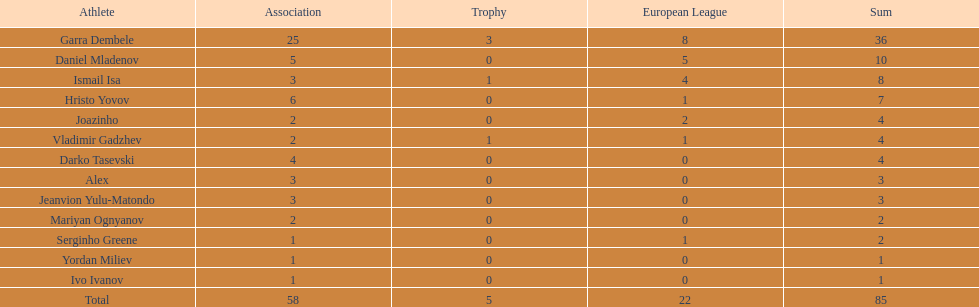Which total is higher, the europa league total or the league total? League. 